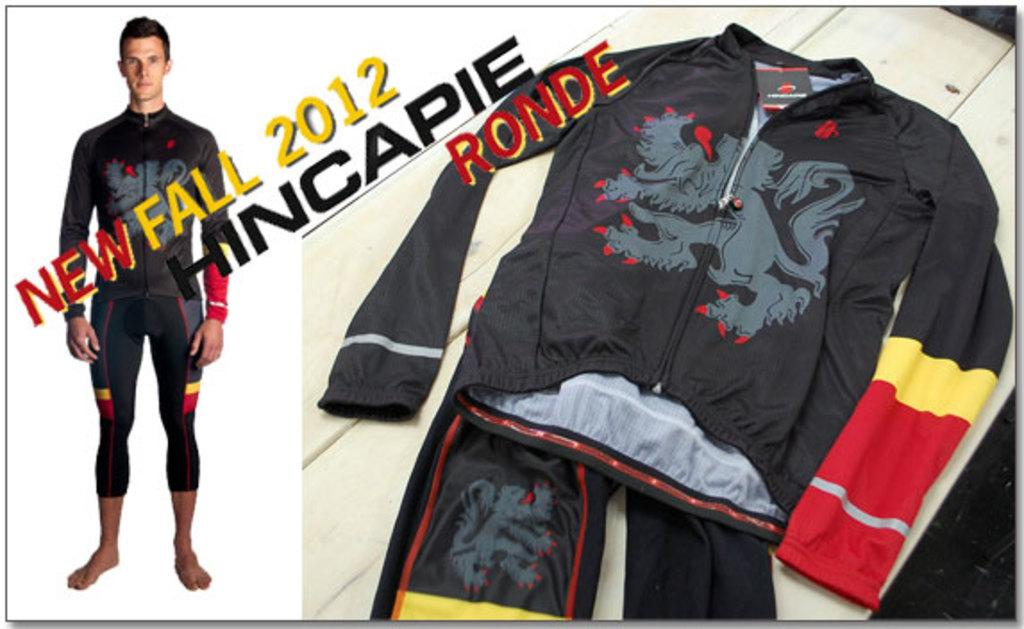<image>
Provide a brief description of the given image. a jacket that has the word Ronde on it 